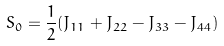Convert formula to latex. <formula><loc_0><loc_0><loc_500><loc_500>S _ { 0 } = \frac { 1 } { 2 } ( J _ { 1 1 } + J _ { 2 2 } - J _ { 3 3 } - J _ { 4 4 } )</formula> 